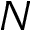<formula> <loc_0><loc_0><loc_500><loc_500>N</formula> 